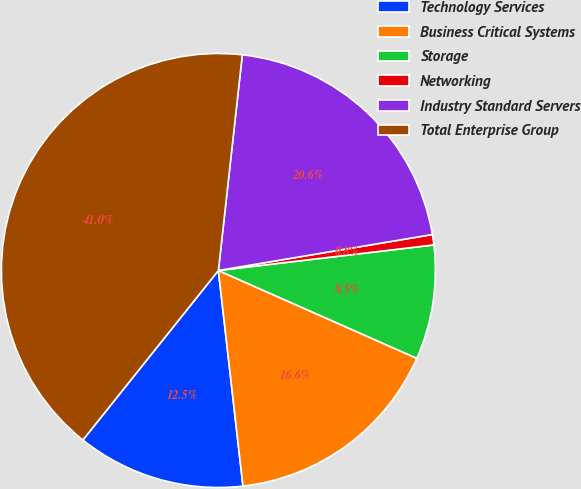<chart> <loc_0><loc_0><loc_500><loc_500><pie_chart><fcel>Technology Services<fcel>Business Critical Systems<fcel>Storage<fcel>Networking<fcel>Industry Standard Servers<fcel>Total Enterprise Group<nl><fcel>12.54%<fcel>16.56%<fcel>8.51%<fcel>0.77%<fcel>20.59%<fcel>41.02%<nl></chart> 